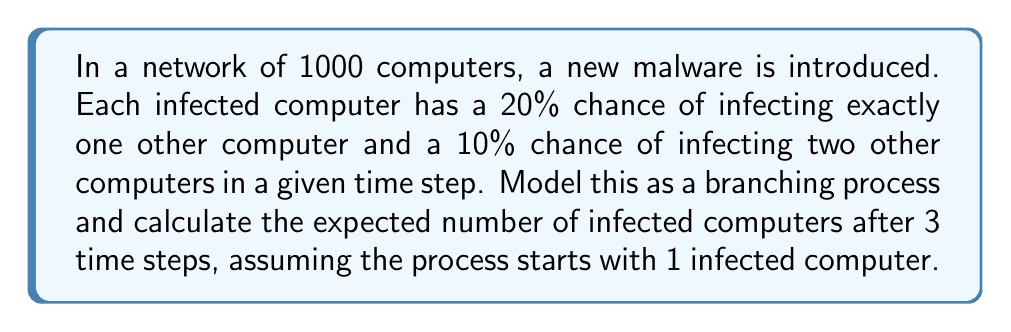Give your solution to this math problem. Let's approach this step-by-step:

1) First, we need to calculate the expected number of new infections caused by a single infected computer in one time step. This is the mean of the offspring distribution, often denoted as $\mu$:

   $\mu = 0 \cdot 0.7 + 1 \cdot 0.2 + 2 \cdot 0.1 = 0.2 + 0.2 = 0.4$

2) In a branching process, the expected number of individuals in the nth generation is given by $\mu^n$, where $n$ is the number of generations (or time steps in our case).

3) After 3 time steps, the expected number of new infections from the initial infection is:

   $0.4^3 = 0.064$

4) However, this doesn't include the initial infected computer. To get the total number of infected computers, we need to sum the expected number in each generation, including the initial infection:

   $1 + 0.4 + 0.4^2 + 0.4^3 = 1 + 0.4 + 0.16 + 0.064 = 1.624$

5) This is the expected number of infected computers after 3 time steps, starting from 1 infected computer.

6) To get the total expected number of infected computers in a network of 1000, we multiply this result by 1000:

   $1000 \cdot 1.624 = 1624$

Thus, after 3 time steps, we expect approximately 1624 computers to be infected in the network of 1000 computers.
Answer: 1624 infected computers 